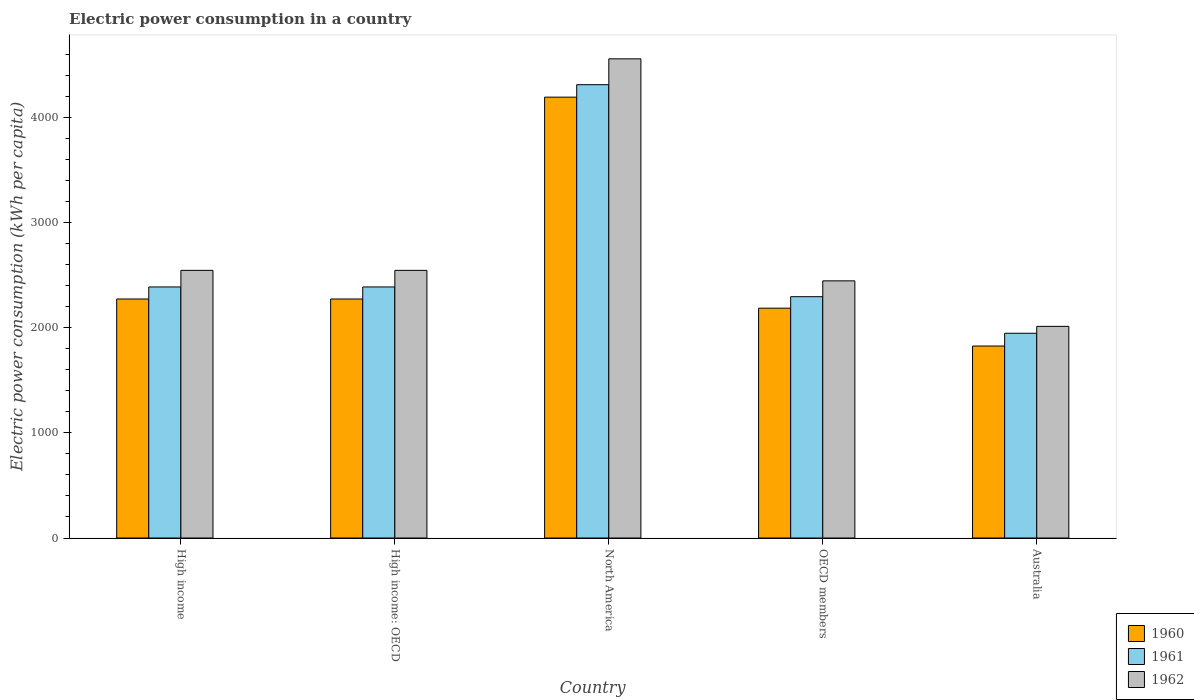How many different coloured bars are there?
Offer a very short reply. 3. Are the number of bars per tick equal to the number of legend labels?
Offer a terse response. Yes. How many bars are there on the 5th tick from the left?
Your response must be concise. 3. How many bars are there on the 4th tick from the right?
Make the answer very short. 3. What is the electric power consumption in in 1962 in High income: OECD?
Your answer should be very brief. 2545.23. Across all countries, what is the maximum electric power consumption in in 1961?
Your answer should be compact. 4310.91. Across all countries, what is the minimum electric power consumption in in 1962?
Your answer should be very brief. 2012.66. In which country was the electric power consumption in in 1962 maximum?
Offer a terse response. North America. In which country was the electric power consumption in in 1962 minimum?
Offer a terse response. Australia. What is the total electric power consumption in in 1960 in the graph?
Make the answer very short. 1.27e+04. What is the difference between the electric power consumption in in 1961 in High income: OECD and that in North America?
Your answer should be very brief. -1923.4. What is the difference between the electric power consumption in in 1962 in High income: OECD and the electric power consumption in in 1961 in Australia?
Provide a short and direct response. 598.08. What is the average electric power consumption in in 1960 per country?
Keep it short and to the point. 2549.89. What is the difference between the electric power consumption in of/in 1962 and electric power consumption in of/in 1961 in High income: OECD?
Your answer should be very brief. 157.73. In how many countries, is the electric power consumption in in 1961 greater than 1800 kWh per capita?
Offer a very short reply. 5. What is the ratio of the electric power consumption in in 1960 in High income: OECD to that in North America?
Ensure brevity in your answer.  0.54. What is the difference between the highest and the second highest electric power consumption in in 1960?
Keep it short and to the point. 1919.38. What is the difference between the highest and the lowest electric power consumption in in 1962?
Your answer should be compact. 2544.12. Is the sum of the electric power consumption in in 1961 in High income and OECD members greater than the maximum electric power consumption in in 1960 across all countries?
Provide a short and direct response. Yes. What does the 1st bar from the left in North America represents?
Make the answer very short. 1960. What does the 3rd bar from the right in High income represents?
Provide a succinct answer. 1960. How many bars are there?
Offer a terse response. 15. What is the difference between two consecutive major ticks on the Y-axis?
Offer a terse response. 1000. Does the graph contain any zero values?
Keep it short and to the point. No. Does the graph contain grids?
Keep it short and to the point. No. How many legend labels are there?
Your response must be concise. 3. What is the title of the graph?
Offer a very short reply. Electric power consumption in a country. What is the label or title of the Y-axis?
Offer a very short reply. Electric power consumption (kWh per capita). What is the Electric power consumption (kWh per capita) of 1960 in High income?
Provide a short and direct response. 2272.98. What is the Electric power consumption (kWh per capita) in 1961 in High income?
Give a very brief answer. 2387.51. What is the Electric power consumption (kWh per capita) in 1962 in High income?
Offer a terse response. 2545.23. What is the Electric power consumption (kWh per capita) of 1960 in High income: OECD?
Give a very brief answer. 2272.98. What is the Electric power consumption (kWh per capita) in 1961 in High income: OECD?
Keep it short and to the point. 2387.51. What is the Electric power consumption (kWh per capita) of 1962 in High income: OECD?
Your response must be concise. 2545.23. What is the Electric power consumption (kWh per capita) in 1960 in North America?
Your response must be concise. 4192.36. What is the Electric power consumption (kWh per capita) of 1961 in North America?
Keep it short and to the point. 4310.91. What is the Electric power consumption (kWh per capita) in 1962 in North America?
Your response must be concise. 4556.78. What is the Electric power consumption (kWh per capita) of 1960 in OECD members?
Your answer should be very brief. 2185.53. What is the Electric power consumption (kWh per capita) of 1961 in OECD members?
Your answer should be very brief. 2294.73. What is the Electric power consumption (kWh per capita) in 1962 in OECD members?
Give a very brief answer. 2445.52. What is the Electric power consumption (kWh per capita) in 1960 in Australia?
Keep it short and to the point. 1825.63. What is the Electric power consumption (kWh per capita) of 1961 in Australia?
Provide a short and direct response. 1947.15. What is the Electric power consumption (kWh per capita) of 1962 in Australia?
Offer a very short reply. 2012.66. Across all countries, what is the maximum Electric power consumption (kWh per capita) of 1960?
Offer a terse response. 4192.36. Across all countries, what is the maximum Electric power consumption (kWh per capita) of 1961?
Your answer should be compact. 4310.91. Across all countries, what is the maximum Electric power consumption (kWh per capita) of 1962?
Your answer should be very brief. 4556.78. Across all countries, what is the minimum Electric power consumption (kWh per capita) in 1960?
Your answer should be very brief. 1825.63. Across all countries, what is the minimum Electric power consumption (kWh per capita) of 1961?
Provide a succinct answer. 1947.15. Across all countries, what is the minimum Electric power consumption (kWh per capita) in 1962?
Ensure brevity in your answer.  2012.66. What is the total Electric power consumption (kWh per capita) in 1960 in the graph?
Give a very brief answer. 1.27e+04. What is the total Electric power consumption (kWh per capita) in 1961 in the graph?
Your response must be concise. 1.33e+04. What is the total Electric power consumption (kWh per capita) of 1962 in the graph?
Offer a terse response. 1.41e+04. What is the difference between the Electric power consumption (kWh per capita) in 1960 in High income and that in High income: OECD?
Your response must be concise. 0. What is the difference between the Electric power consumption (kWh per capita) of 1961 in High income and that in High income: OECD?
Make the answer very short. 0. What is the difference between the Electric power consumption (kWh per capita) of 1962 in High income and that in High income: OECD?
Keep it short and to the point. 0. What is the difference between the Electric power consumption (kWh per capita) of 1960 in High income and that in North America?
Offer a very short reply. -1919.38. What is the difference between the Electric power consumption (kWh per capita) of 1961 in High income and that in North America?
Ensure brevity in your answer.  -1923.4. What is the difference between the Electric power consumption (kWh per capita) of 1962 in High income and that in North America?
Make the answer very short. -2011.55. What is the difference between the Electric power consumption (kWh per capita) of 1960 in High income and that in OECD members?
Your answer should be compact. 87.44. What is the difference between the Electric power consumption (kWh per capita) in 1961 in High income and that in OECD members?
Give a very brief answer. 92.77. What is the difference between the Electric power consumption (kWh per capita) of 1962 in High income and that in OECD members?
Provide a succinct answer. 99.71. What is the difference between the Electric power consumption (kWh per capita) in 1960 in High income and that in Australia?
Give a very brief answer. 447.35. What is the difference between the Electric power consumption (kWh per capita) in 1961 in High income and that in Australia?
Offer a terse response. 440.35. What is the difference between the Electric power consumption (kWh per capita) in 1962 in High income and that in Australia?
Provide a succinct answer. 532.57. What is the difference between the Electric power consumption (kWh per capita) in 1960 in High income: OECD and that in North America?
Your answer should be very brief. -1919.38. What is the difference between the Electric power consumption (kWh per capita) in 1961 in High income: OECD and that in North America?
Keep it short and to the point. -1923.4. What is the difference between the Electric power consumption (kWh per capita) in 1962 in High income: OECD and that in North America?
Provide a short and direct response. -2011.55. What is the difference between the Electric power consumption (kWh per capita) of 1960 in High income: OECD and that in OECD members?
Make the answer very short. 87.44. What is the difference between the Electric power consumption (kWh per capita) of 1961 in High income: OECD and that in OECD members?
Offer a terse response. 92.77. What is the difference between the Electric power consumption (kWh per capita) of 1962 in High income: OECD and that in OECD members?
Your answer should be very brief. 99.71. What is the difference between the Electric power consumption (kWh per capita) in 1960 in High income: OECD and that in Australia?
Provide a succinct answer. 447.35. What is the difference between the Electric power consumption (kWh per capita) of 1961 in High income: OECD and that in Australia?
Provide a succinct answer. 440.35. What is the difference between the Electric power consumption (kWh per capita) in 1962 in High income: OECD and that in Australia?
Give a very brief answer. 532.57. What is the difference between the Electric power consumption (kWh per capita) of 1960 in North America and that in OECD members?
Offer a very short reply. 2006.82. What is the difference between the Electric power consumption (kWh per capita) of 1961 in North America and that in OECD members?
Keep it short and to the point. 2016.17. What is the difference between the Electric power consumption (kWh per capita) in 1962 in North America and that in OECD members?
Your response must be concise. 2111.25. What is the difference between the Electric power consumption (kWh per capita) in 1960 in North America and that in Australia?
Make the answer very short. 2366.73. What is the difference between the Electric power consumption (kWh per capita) in 1961 in North America and that in Australia?
Provide a succinct answer. 2363.75. What is the difference between the Electric power consumption (kWh per capita) in 1962 in North America and that in Australia?
Make the answer very short. 2544.12. What is the difference between the Electric power consumption (kWh per capita) in 1960 in OECD members and that in Australia?
Ensure brevity in your answer.  359.91. What is the difference between the Electric power consumption (kWh per capita) in 1961 in OECD members and that in Australia?
Make the answer very short. 347.58. What is the difference between the Electric power consumption (kWh per capita) in 1962 in OECD members and that in Australia?
Make the answer very short. 432.86. What is the difference between the Electric power consumption (kWh per capita) in 1960 in High income and the Electric power consumption (kWh per capita) in 1961 in High income: OECD?
Make the answer very short. -114.53. What is the difference between the Electric power consumption (kWh per capita) in 1960 in High income and the Electric power consumption (kWh per capita) in 1962 in High income: OECD?
Offer a very short reply. -272.26. What is the difference between the Electric power consumption (kWh per capita) of 1961 in High income and the Electric power consumption (kWh per capita) of 1962 in High income: OECD?
Provide a short and direct response. -157.73. What is the difference between the Electric power consumption (kWh per capita) of 1960 in High income and the Electric power consumption (kWh per capita) of 1961 in North America?
Provide a succinct answer. -2037.93. What is the difference between the Electric power consumption (kWh per capita) of 1960 in High income and the Electric power consumption (kWh per capita) of 1962 in North America?
Make the answer very short. -2283.8. What is the difference between the Electric power consumption (kWh per capita) of 1961 in High income and the Electric power consumption (kWh per capita) of 1962 in North America?
Your answer should be compact. -2169.27. What is the difference between the Electric power consumption (kWh per capita) of 1960 in High income and the Electric power consumption (kWh per capita) of 1961 in OECD members?
Keep it short and to the point. -21.76. What is the difference between the Electric power consumption (kWh per capita) in 1960 in High income and the Electric power consumption (kWh per capita) in 1962 in OECD members?
Offer a very short reply. -172.55. What is the difference between the Electric power consumption (kWh per capita) of 1961 in High income and the Electric power consumption (kWh per capita) of 1962 in OECD members?
Keep it short and to the point. -58.02. What is the difference between the Electric power consumption (kWh per capita) of 1960 in High income and the Electric power consumption (kWh per capita) of 1961 in Australia?
Your response must be concise. 325.82. What is the difference between the Electric power consumption (kWh per capita) in 1960 in High income and the Electric power consumption (kWh per capita) in 1962 in Australia?
Your answer should be very brief. 260.32. What is the difference between the Electric power consumption (kWh per capita) in 1961 in High income and the Electric power consumption (kWh per capita) in 1962 in Australia?
Your answer should be compact. 374.84. What is the difference between the Electric power consumption (kWh per capita) of 1960 in High income: OECD and the Electric power consumption (kWh per capita) of 1961 in North America?
Give a very brief answer. -2037.93. What is the difference between the Electric power consumption (kWh per capita) of 1960 in High income: OECD and the Electric power consumption (kWh per capita) of 1962 in North America?
Offer a very short reply. -2283.8. What is the difference between the Electric power consumption (kWh per capita) in 1961 in High income: OECD and the Electric power consumption (kWh per capita) in 1962 in North America?
Your answer should be very brief. -2169.27. What is the difference between the Electric power consumption (kWh per capita) of 1960 in High income: OECD and the Electric power consumption (kWh per capita) of 1961 in OECD members?
Your answer should be very brief. -21.76. What is the difference between the Electric power consumption (kWh per capita) in 1960 in High income: OECD and the Electric power consumption (kWh per capita) in 1962 in OECD members?
Provide a succinct answer. -172.55. What is the difference between the Electric power consumption (kWh per capita) of 1961 in High income: OECD and the Electric power consumption (kWh per capita) of 1962 in OECD members?
Your answer should be compact. -58.02. What is the difference between the Electric power consumption (kWh per capita) of 1960 in High income: OECD and the Electric power consumption (kWh per capita) of 1961 in Australia?
Provide a succinct answer. 325.82. What is the difference between the Electric power consumption (kWh per capita) of 1960 in High income: OECD and the Electric power consumption (kWh per capita) of 1962 in Australia?
Your answer should be compact. 260.32. What is the difference between the Electric power consumption (kWh per capita) of 1961 in High income: OECD and the Electric power consumption (kWh per capita) of 1962 in Australia?
Make the answer very short. 374.84. What is the difference between the Electric power consumption (kWh per capita) in 1960 in North America and the Electric power consumption (kWh per capita) in 1961 in OECD members?
Your answer should be compact. 1897.62. What is the difference between the Electric power consumption (kWh per capita) of 1960 in North America and the Electric power consumption (kWh per capita) of 1962 in OECD members?
Your answer should be very brief. 1746.83. What is the difference between the Electric power consumption (kWh per capita) in 1961 in North America and the Electric power consumption (kWh per capita) in 1962 in OECD members?
Make the answer very short. 1865.38. What is the difference between the Electric power consumption (kWh per capita) of 1960 in North America and the Electric power consumption (kWh per capita) of 1961 in Australia?
Your answer should be very brief. 2245.2. What is the difference between the Electric power consumption (kWh per capita) of 1960 in North America and the Electric power consumption (kWh per capita) of 1962 in Australia?
Your answer should be very brief. 2179.7. What is the difference between the Electric power consumption (kWh per capita) in 1961 in North America and the Electric power consumption (kWh per capita) in 1962 in Australia?
Ensure brevity in your answer.  2298.24. What is the difference between the Electric power consumption (kWh per capita) of 1960 in OECD members and the Electric power consumption (kWh per capita) of 1961 in Australia?
Make the answer very short. 238.38. What is the difference between the Electric power consumption (kWh per capita) in 1960 in OECD members and the Electric power consumption (kWh per capita) in 1962 in Australia?
Offer a terse response. 172.87. What is the difference between the Electric power consumption (kWh per capita) of 1961 in OECD members and the Electric power consumption (kWh per capita) of 1962 in Australia?
Offer a very short reply. 282.07. What is the average Electric power consumption (kWh per capita) in 1960 per country?
Your answer should be compact. 2549.89. What is the average Electric power consumption (kWh per capita) in 1961 per country?
Provide a succinct answer. 2665.56. What is the average Electric power consumption (kWh per capita) in 1962 per country?
Your response must be concise. 2821.08. What is the difference between the Electric power consumption (kWh per capita) of 1960 and Electric power consumption (kWh per capita) of 1961 in High income?
Keep it short and to the point. -114.53. What is the difference between the Electric power consumption (kWh per capita) in 1960 and Electric power consumption (kWh per capita) in 1962 in High income?
Give a very brief answer. -272.26. What is the difference between the Electric power consumption (kWh per capita) of 1961 and Electric power consumption (kWh per capita) of 1962 in High income?
Your response must be concise. -157.73. What is the difference between the Electric power consumption (kWh per capita) of 1960 and Electric power consumption (kWh per capita) of 1961 in High income: OECD?
Your answer should be compact. -114.53. What is the difference between the Electric power consumption (kWh per capita) of 1960 and Electric power consumption (kWh per capita) of 1962 in High income: OECD?
Your response must be concise. -272.26. What is the difference between the Electric power consumption (kWh per capita) in 1961 and Electric power consumption (kWh per capita) in 1962 in High income: OECD?
Your response must be concise. -157.73. What is the difference between the Electric power consumption (kWh per capita) in 1960 and Electric power consumption (kWh per capita) in 1961 in North America?
Keep it short and to the point. -118.55. What is the difference between the Electric power consumption (kWh per capita) of 1960 and Electric power consumption (kWh per capita) of 1962 in North America?
Make the answer very short. -364.42. What is the difference between the Electric power consumption (kWh per capita) of 1961 and Electric power consumption (kWh per capita) of 1962 in North America?
Provide a short and direct response. -245.87. What is the difference between the Electric power consumption (kWh per capita) in 1960 and Electric power consumption (kWh per capita) in 1961 in OECD members?
Provide a short and direct response. -109.2. What is the difference between the Electric power consumption (kWh per capita) of 1960 and Electric power consumption (kWh per capita) of 1962 in OECD members?
Your response must be concise. -259.99. What is the difference between the Electric power consumption (kWh per capita) of 1961 and Electric power consumption (kWh per capita) of 1962 in OECD members?
Give a very brief answer. -150.79. What is the difference between the Electric power consumption (kWh per capita) of 1960 and Electric power consumption (kWh per capita) of 1961 in Australia?
Your answer should be very brief. -121.53. What is the difference between the Electric power consumption (kWh per capita) in 1960 and Electric power consumption (kWh per capita) in 1962 in Australia?
Give a very brief answer. -187.03. What is the difference between the Electric power consumption (kWh per capita) in 1961 and Electric power consumption (kWh per capita) in 1962 in Australia?
Offer a terse response. -65.51. What is the ratio of the Electric power consumption (kWh per capita) in 1960 in High income to that in North America?
Keep it short and to the point. 0.54. What is the ratio of the Electric power consumption (kWh per capita) of 1961 in High income to that in North America?
Provide a succinct answer. 0.55. What is the ratio of the Electric power consumption (kWh per capita) of 1962 in High income to that in North America?
Your answer should be compact. 0.56. What is the ratio of the Electric power consumption (kWh per capita) in 1961 in High income to that in OECD members?
Offer a very short reply. 1.04. What is the ratio of the Electric power consumption (kWh per capita) of 1962 in High income to that in OECD members?
Provide a short and direct response. 1.04. What is the ratio of the Electric power consumption (kWh per capita) of 1960 in High income to that in Australia?
Ensure brevity in your answer.  1.25. What is the ratio of the Electric power consumption (kWh per capita) of 1961 in High income to that in Australia?
Give a very brief answer. 1.23. What is the ratio of the Electric power consumption (kWh per capita) in 1962 in High income to that in Australia?
Provide a short and direct response. 1.26. What is the ratio of the Electric power consumption (kWh per capita) of 1960 in High income: OECD to that in North America?
Your answer should be compact. 0.54. What is the ratio of the Electric power consumption (kWh per capita) of 1961 in High income: OECD to that in North America?
Your answer should be very brief. 0.55. What is the ratio of the Electric power consumption (kWh per capita) in 1962 in High income: OECD to that in North America?
Your answer should be compact. 0.56. What is the ratio of the Electric power consumption (kWh per capita) of 1961 in High income: OECD to that in OECD members?
Offer a terse response. 1.04. What is the ratio of the Electric power consumption (kWh per capita) in 1962 in High income: OECD to that in OECD members?
Provide a succinct answer. 1.04. What is the ratio of the Electric power consumption (kWh per capita) in 1960 in High income: OECD to that in Australia?
Give a very brief answer. 1.25. What is the ratio of the Electric power consumption (kWh per capita) of 1961 in High income: OECD to that in Australia?
Provide a short and direct response. 1.23. What is the ratio of the Electric power consumption (kWh per capita) of 1962 in High income: OECD to that in Australia?
Provide a short and direct response. 1.26. What is the ratio of the Electric power consumption (kWh per capita) of 1960 in North America to that in OECD members?
Make the answer very short. 1.92. What is the ratio of the Electric power consumption (kWh per capita) of 1961 in North America to that in OECD members?
Offer a very short reply. 1.88. What is the ratio of the Electric power consumption (kWh per capita) in 1962 in North America to that in OECD members?
Ensure brevity in your answer.  1.86. What is the ratio of the Electric power consumption (kWh per capita) of 1960 in North America to that in Australia?
Your answer should be compact. 2.3. What is the ratio of the Electric power consumption (kWh per capita) of 1961 in North America to that in Australia?
Offer a very short reply. 2.21. What is the ratio of the Electric power consumption (kWh per capita) in 1962 in North America to that in Australia?
Provide a succinct answer. 2.26. What is the ratio of the Electric power consumption (kWh per capita) in 1960 in OECD members to that in Australia?
Your answer should be compact. 1.2. What is the ratio of the Electric power consumption (kWh per capita) of 1961 in OECD members to that in Australia?
Offer a terse response. 1.18. What is the ratio of the Electric power consumption (kWh per capita) in 1962 in OECD members to that in Australia?
Provide a succinct answer. 1.22. What is the difference between the highest and the second highest Electric power consumption (kWh per capita) in 1960?
Make the answer very short. 1919.38. What is the difference between the highest and the second highest Electric power consumption (kWh per capita) of 1961?
Offer a very short reply. 1923.4. What is the difference between the highest and the second highest Electric power consumption (kWh per capita) in 1962?
Your answer should be compact. 2011.55. What is the difference between the highest and the lowest Electric power consumption (kWh per capita) of 1960?
Give a very brief answer. 2366.73. What is the difference between the highest and the lowest Electric power consumption (kWh per capita) of 1961?
Your answer should be compact. 2363.75. What is the difference between the highest and the lowest Electric power consumption (kWh per capita) in 1962?
Offer a terse response. 2544.12. 